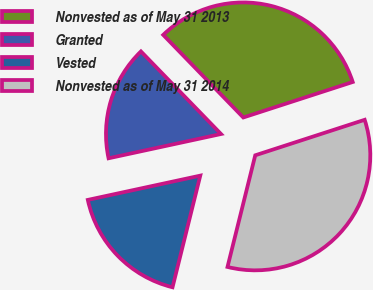Convert chart to OTSL. <chart><loc_0><loc_0><loc_500><loc_500><pie_chart><fcel>Nonvested as of May 31 2013<fcel>Granted<fcel>Vested<fcel>Nonvested as of May 31 2014<nl><fcel>32.26%<fcel>16.13%<fcel>17.74%<fcel>33.87%<nl></chart> 